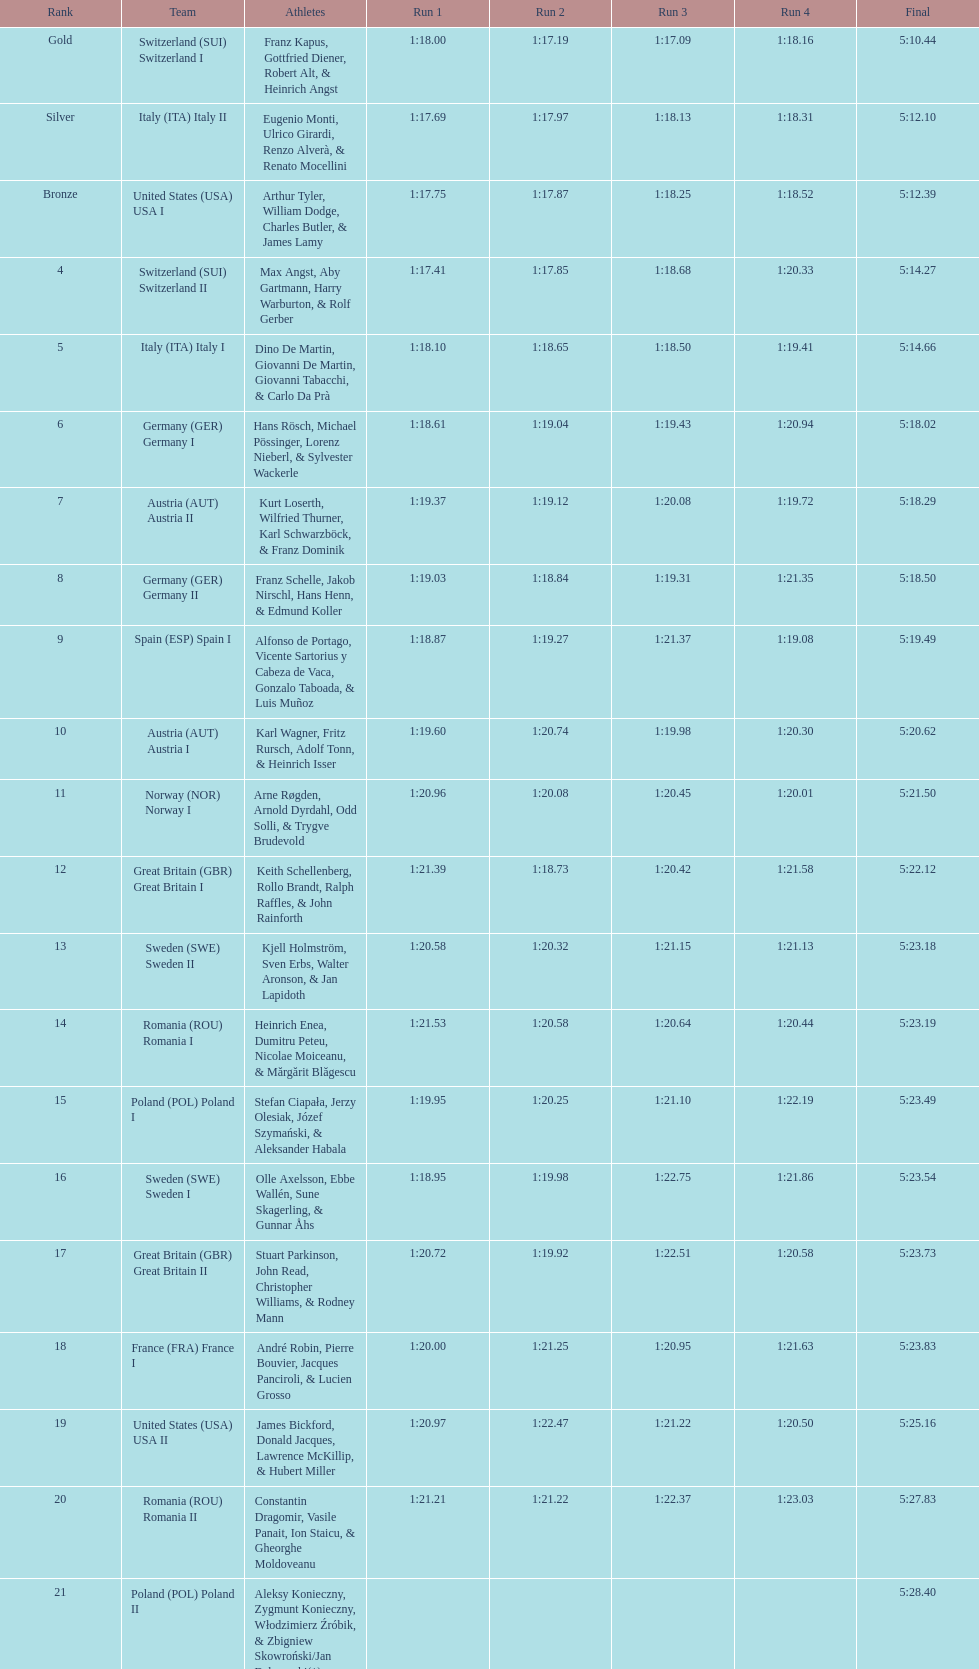Who is the previous team to italy (ita) italy ii? Switzerland (SUI) Switzerland I. 